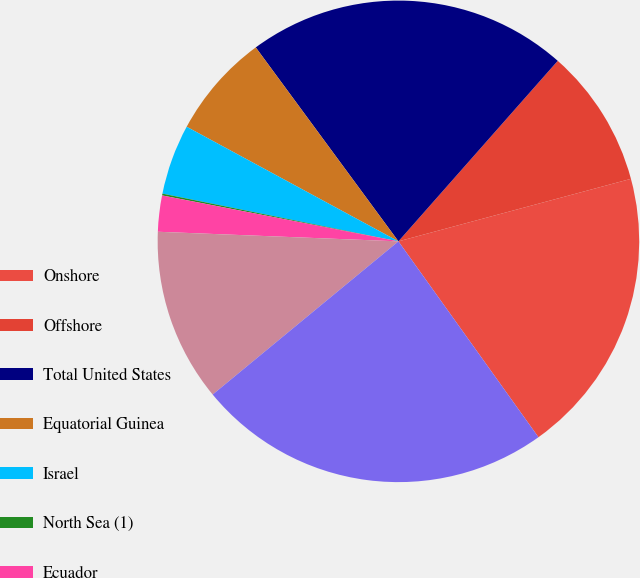Convert chart. <chart><loc_0><loc_0><loc_500><loc_500><pie_chart><fcel>Onshore<fcel>Offshore<fcel>Total United States<fcel>Equatorial Guinea<fcel>Israel<fcel>North Sea (1)<fcel>Ecuador<fcel>Total International<fcel>Total (2)<nl><fcel>19.3%<fcel>9.31%<fcel>21.6%<fcel>7.01%<fcel>4.72%<fcel>0.12%<fcel>2.42%<fcel>11.61%<fcel>23.9%<nl></chart> 